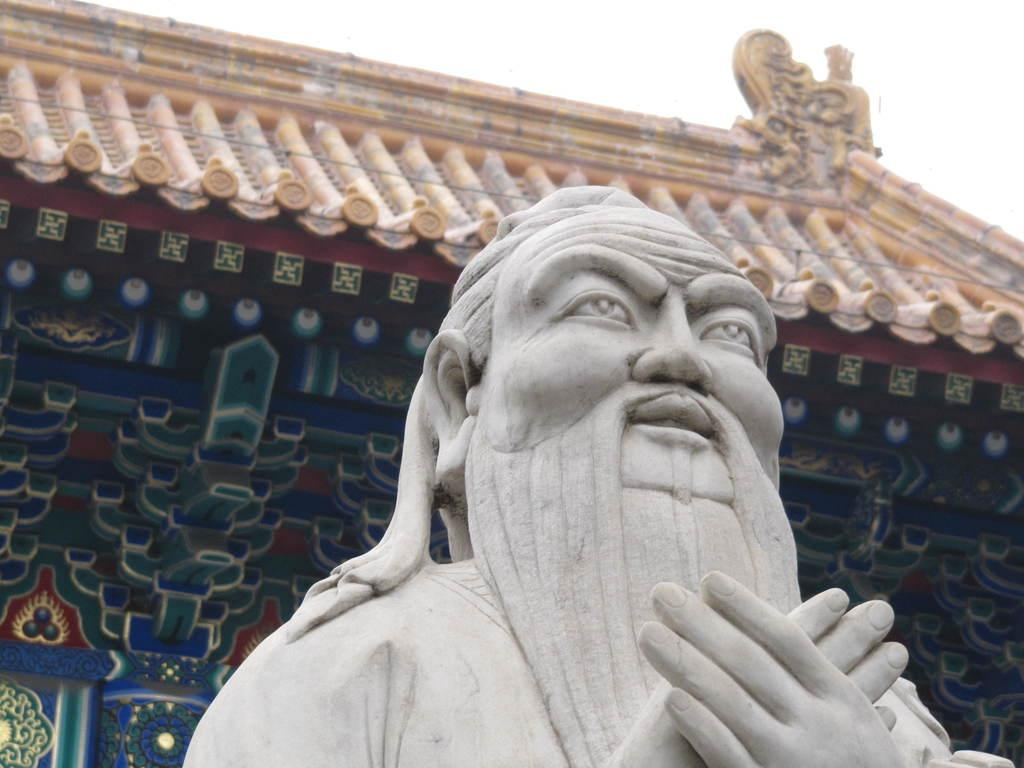What is the main subject in the image? There is a statue in the image. What other element can be seen in the image besides the statue? There is an architecture in the image. What can be seen in the background of the image? The sky is visible behind the architecture. What type of linen is draped over the statue in the image? There is no linen present in the image; the statue is not covered by any fabric. 